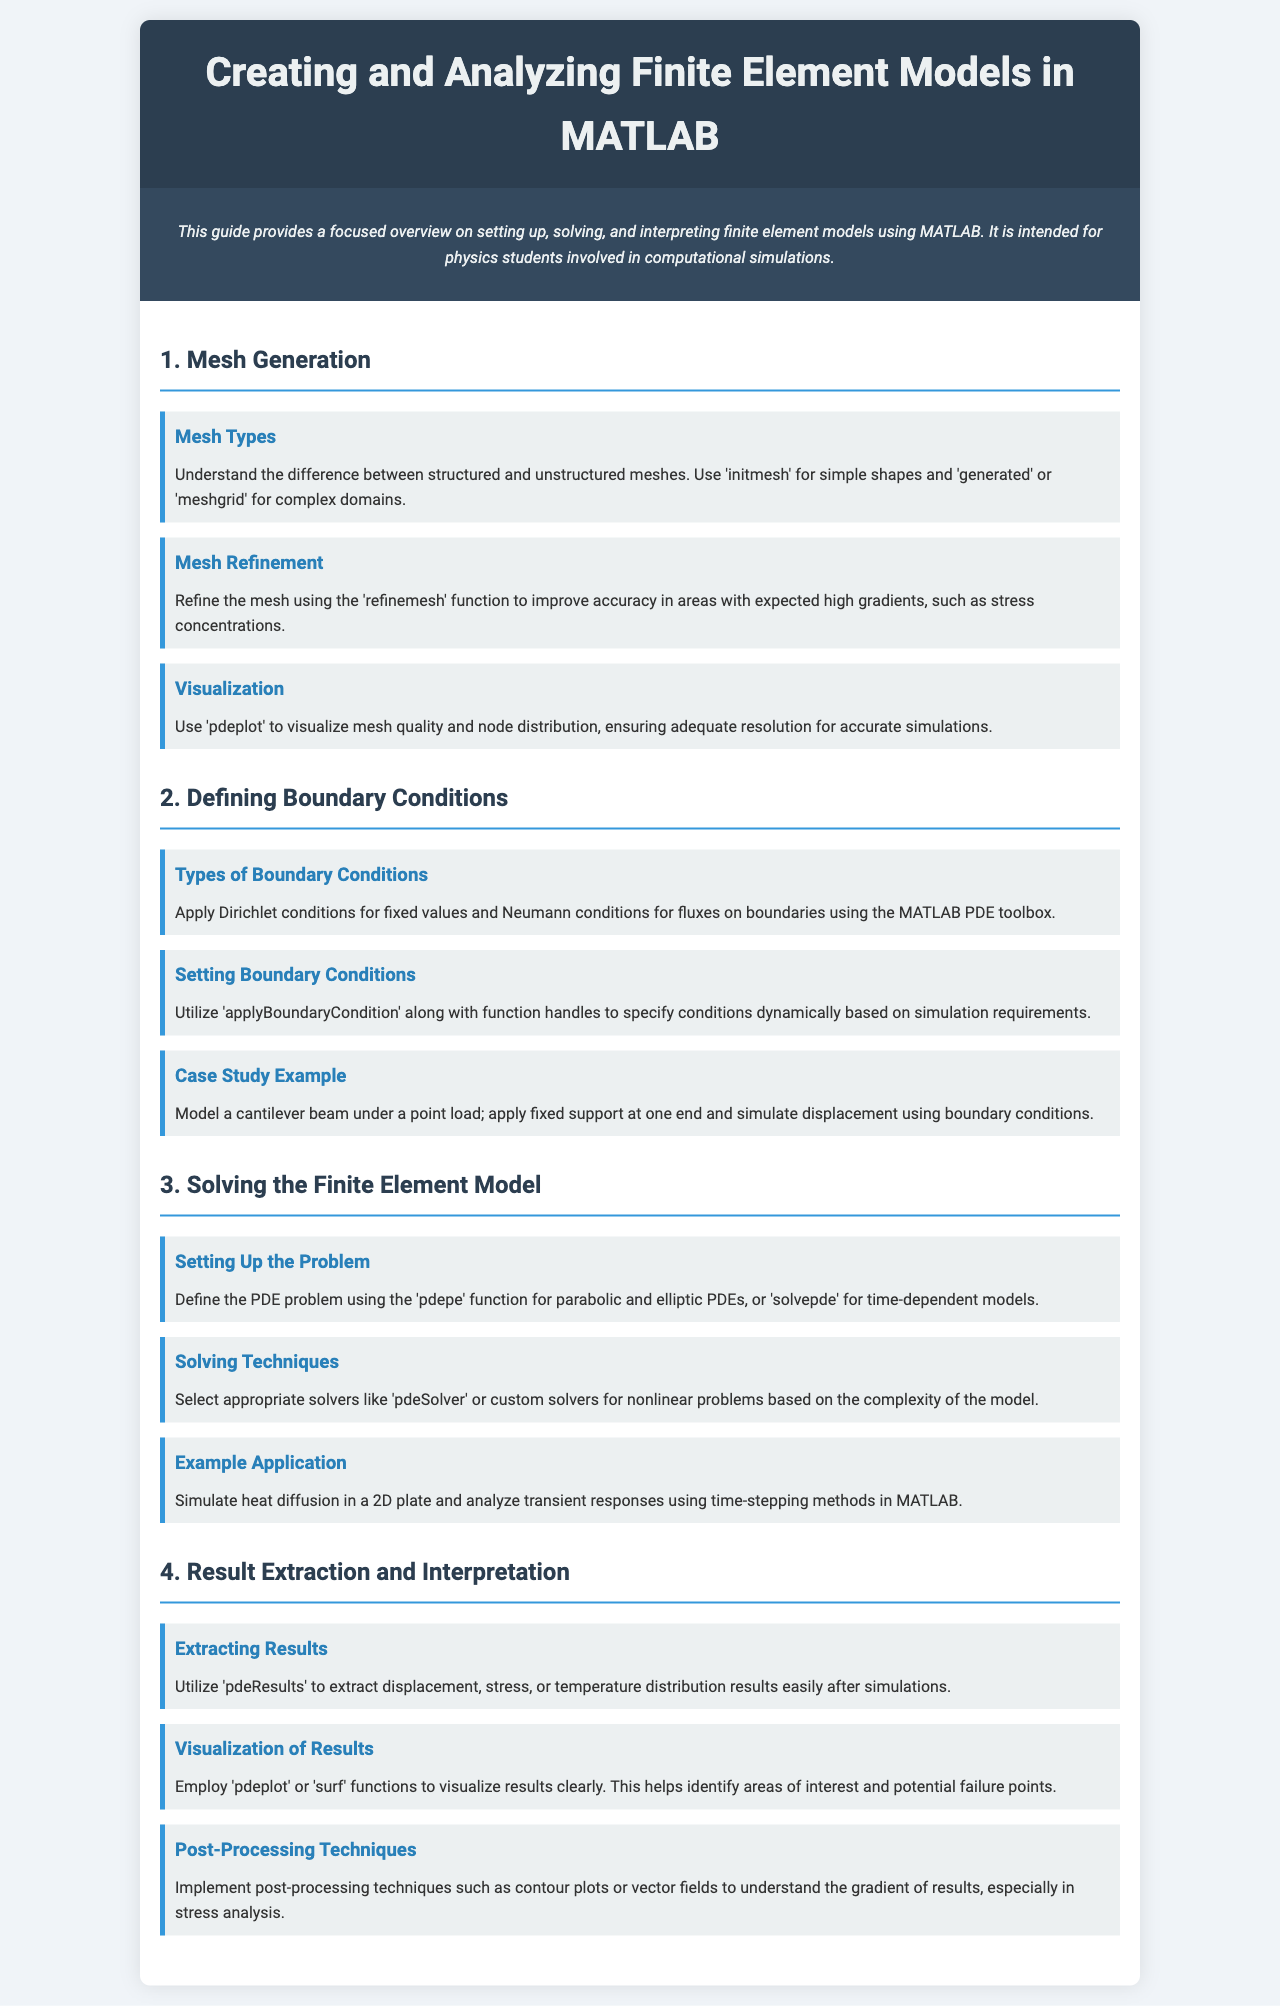What are the types of meshes mentioned? The document specifies that structured and unstructured meshes are the two types of meshes used in finite element models.
Answer: Structured and unstructured What function is used for mesh refinement? The document states that 'refinemesh' is the function utilized to refine the mesh for better accuracy.
Answer: refinemech What type of boundary condition is applied for fixed values? It explains that Dirichlet conditions are used for fixed values in boundary conditions.
Answer: Dirichlet Which function is utilized to specify boundary conditions dynamically? 'applyBoundaryCondition' is the function mentioned for specifying boundary conditions dynamically.
Answer: applyBoundaryCondition What is the primary function for defining the PDE problem? The document highlights that 'pdepe' is used for defining the PDE problem for parabolic and elliptic PDEs.
Answer: pdepe How can results be visualized after simulations? The document suggests using 'pdeplot' or 'surf' functions to visualize results clearly.
Answer: pdeplot or surf What technique can be implemented for understanding result gradients? It mentions that contour plots or vector fields can be implemented as post-processing techniques.
Answer: Contour plots or vector fields What type of model is used in the example application for heat diffusion? The example application focuses on simulating heat diffusion in a 2D plate.
Answer: 2D plate Name one solver selected for nonlinear problems. The document discusses selecting solvers like 'pdeSolver' for nonlinear problems.
Answer: pdeSolver 